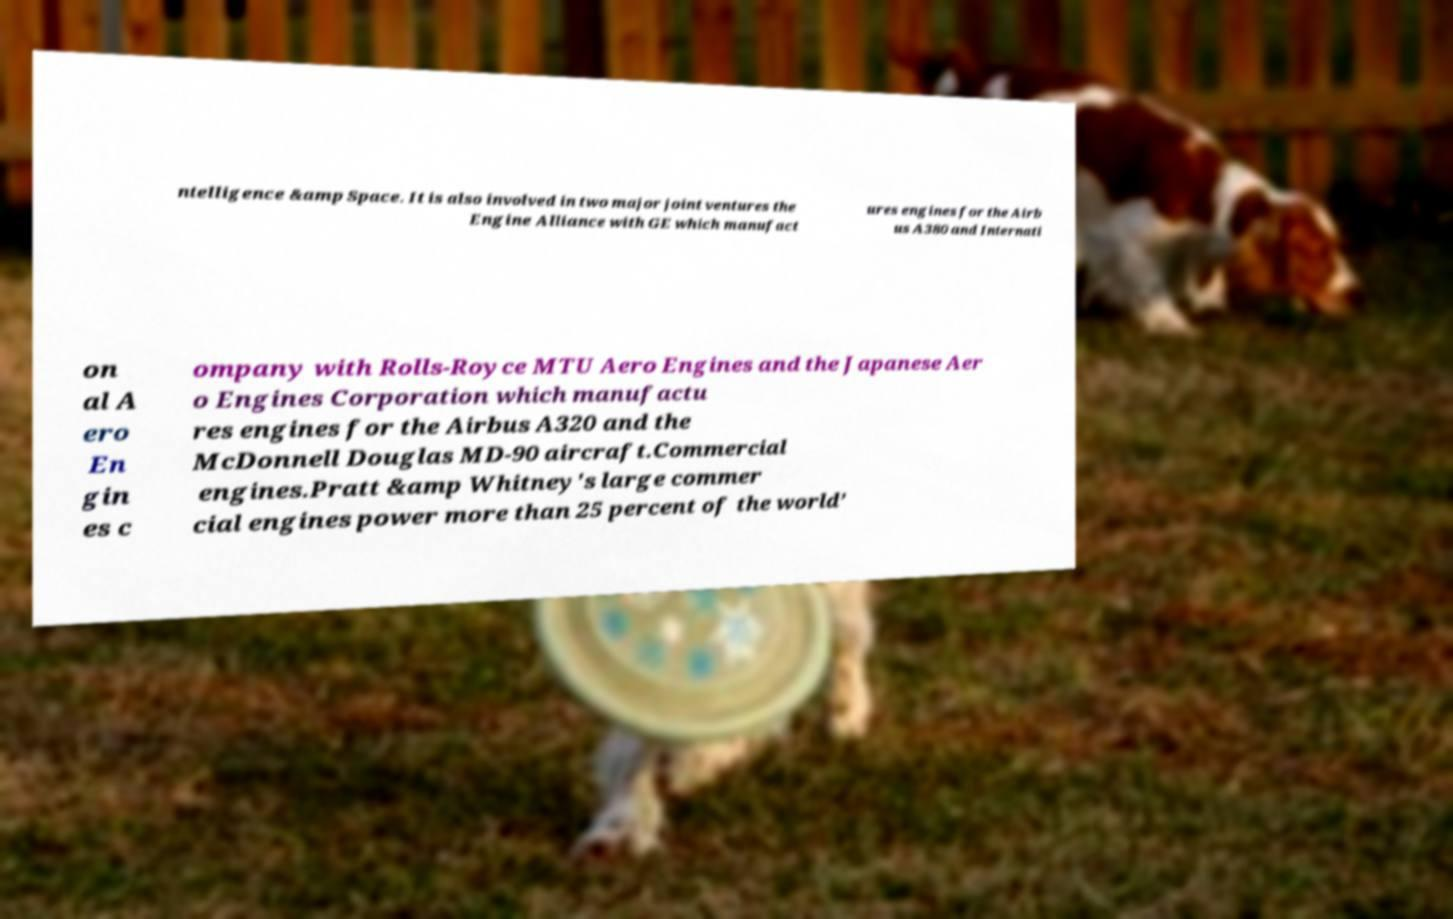For documentation purposes, I need the text within this image transcribed. Could you provide that? ntelligence &amp Space. It is also involved in two major joint ventures the Engine Alliance with GE which manufact ures engines for the Airb us A380 and Internati on al A ero En gin es c ompany with Rolls-Royce MTU Aero Engines and the Japanese Aer o Engines Corporation which manufactu res engines for the Airbus A320 and the McDonnell Douglas MD-90 aircraft.Commercial engines.Pratt &amp Whitney's large commer cial engines power more than 25 percent of the world’ 